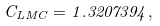Convert formula to latex. <formula><loc_0><loc_0><loc_500><loc_500>C _ { L M C } = 1 . 3 2 0 7 3 9 4 ,</formula> 